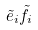Convert formula to latex. <formula><loc_0><loc_0><loc_500><loc_500>\tilde { e } _ { i } \tilde { f } _ { i }</formula> 